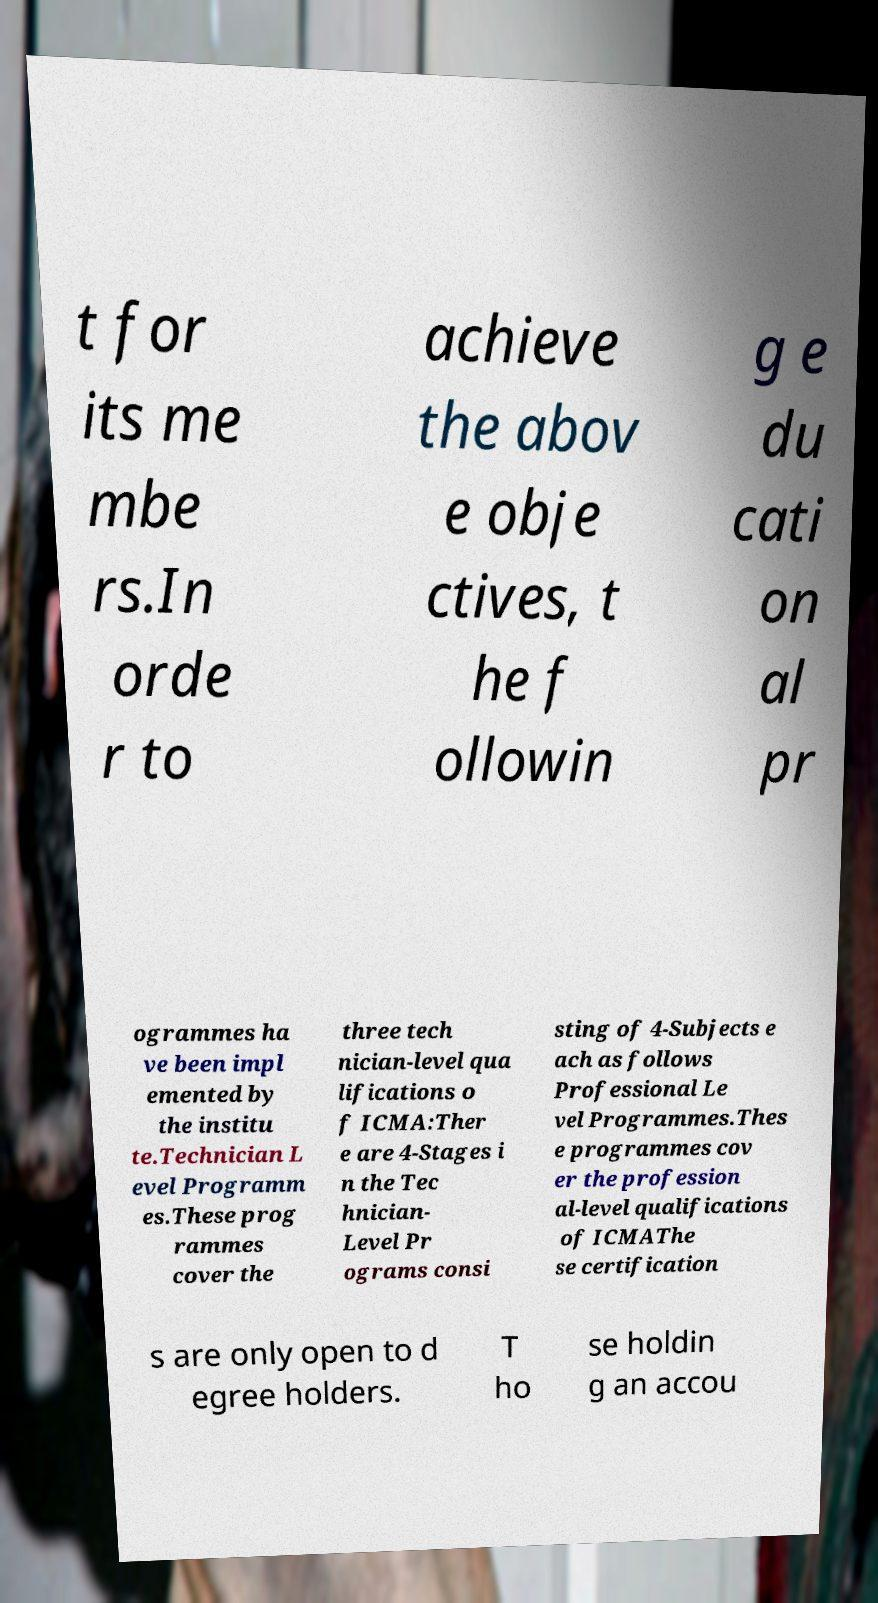I need the written content from this picture converted into text. Can you do that? t for its me mbe rs.In orde r to achieve the abov e obje ctives, t he f ollowin g e du cati on al pr ogrammes ha ve been impl emented by the institu te.Technician L evel Programm es.These prog rammes cover the three tech nician-level qua lifications o f ICMA:Ther e are 4-Stages i n the Tec hnician- Level Pr ograms consi sting of 4-Subjects e ach as follows Professional Le vel Programmes.Thes e programmes cov er the profession al-level qualifications of ICMAThe se certification s are only open to d egree holders. T ho se holdin g an accou 